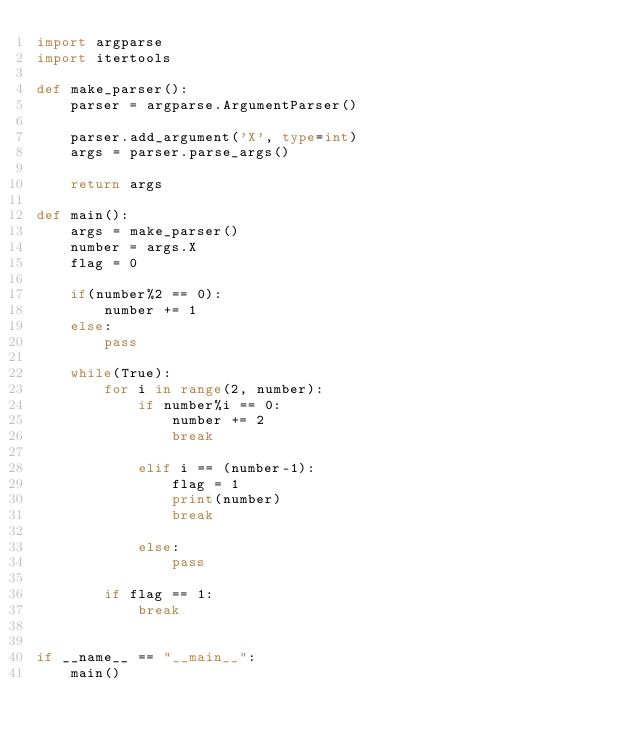Convert code to text. <code><loc_0><loc_0><loc_500><loc_500><_Python_>import argparse
import itertools

def make_parser():
    parser = argparse.ArgumentParser()

    parser.add_argument('X', type=int)
    args = parser.parse_args()

    return args

def main():
    args = make_parser()
    number = args.X
    flag = 0

    if(number%2 == 0):
        number += 1
    else:
        pass

    while(True):
        for i in range(2, number):
            if number%i == 0:
                number += 2
                break

            elif i == (number-1):
                flag = 1
                print(number)
                break

            else:
                pass

        if flag == 1:
            break


if __name__ == "__main__":
    main()
</code> 